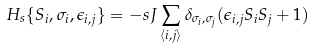Convert formula to latex. <formula><loc_0><loc_0><loc_500><loc_500>H _ { s } \{ S _ { i } , \sigma _ { i } , \epsilon _ { i , j } \} = - s J \sum _ { \langle i , j \rangle } \delta _ { \sigma _ { i } , \sigma _ { j } } ( \epsilon _ { i , j } S _ { i } S _ { j } + 1 )</formula> 